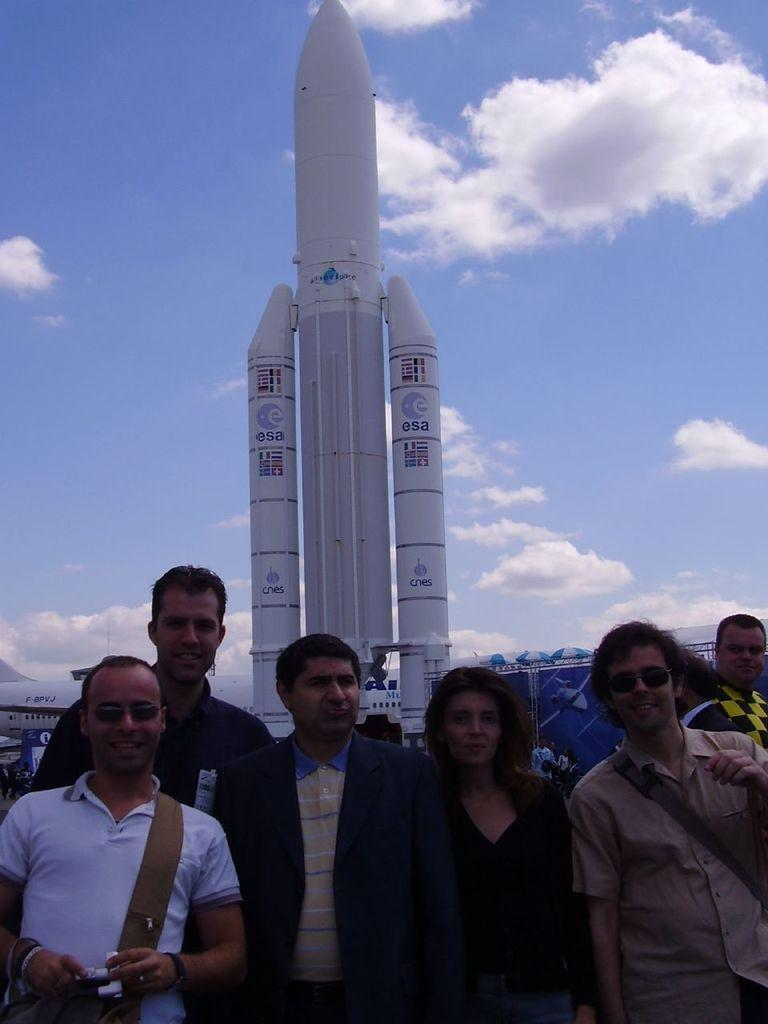What is happening in the image? There are people standing in the image. What can be seen in the background of the image? There is an airplane, a rocket, and banners in the background of the image. How would you describe the sky in the image? The sky is blue with clouds in the background of the image. What type of authority figure is present in the image? There is no authority figure present in the image. Can you describe the quilt that the people are sitting on in the image? There is no quilt present in the image; the people are standing. How many frogs can be seen in the image? There are no frogs present in the image. 